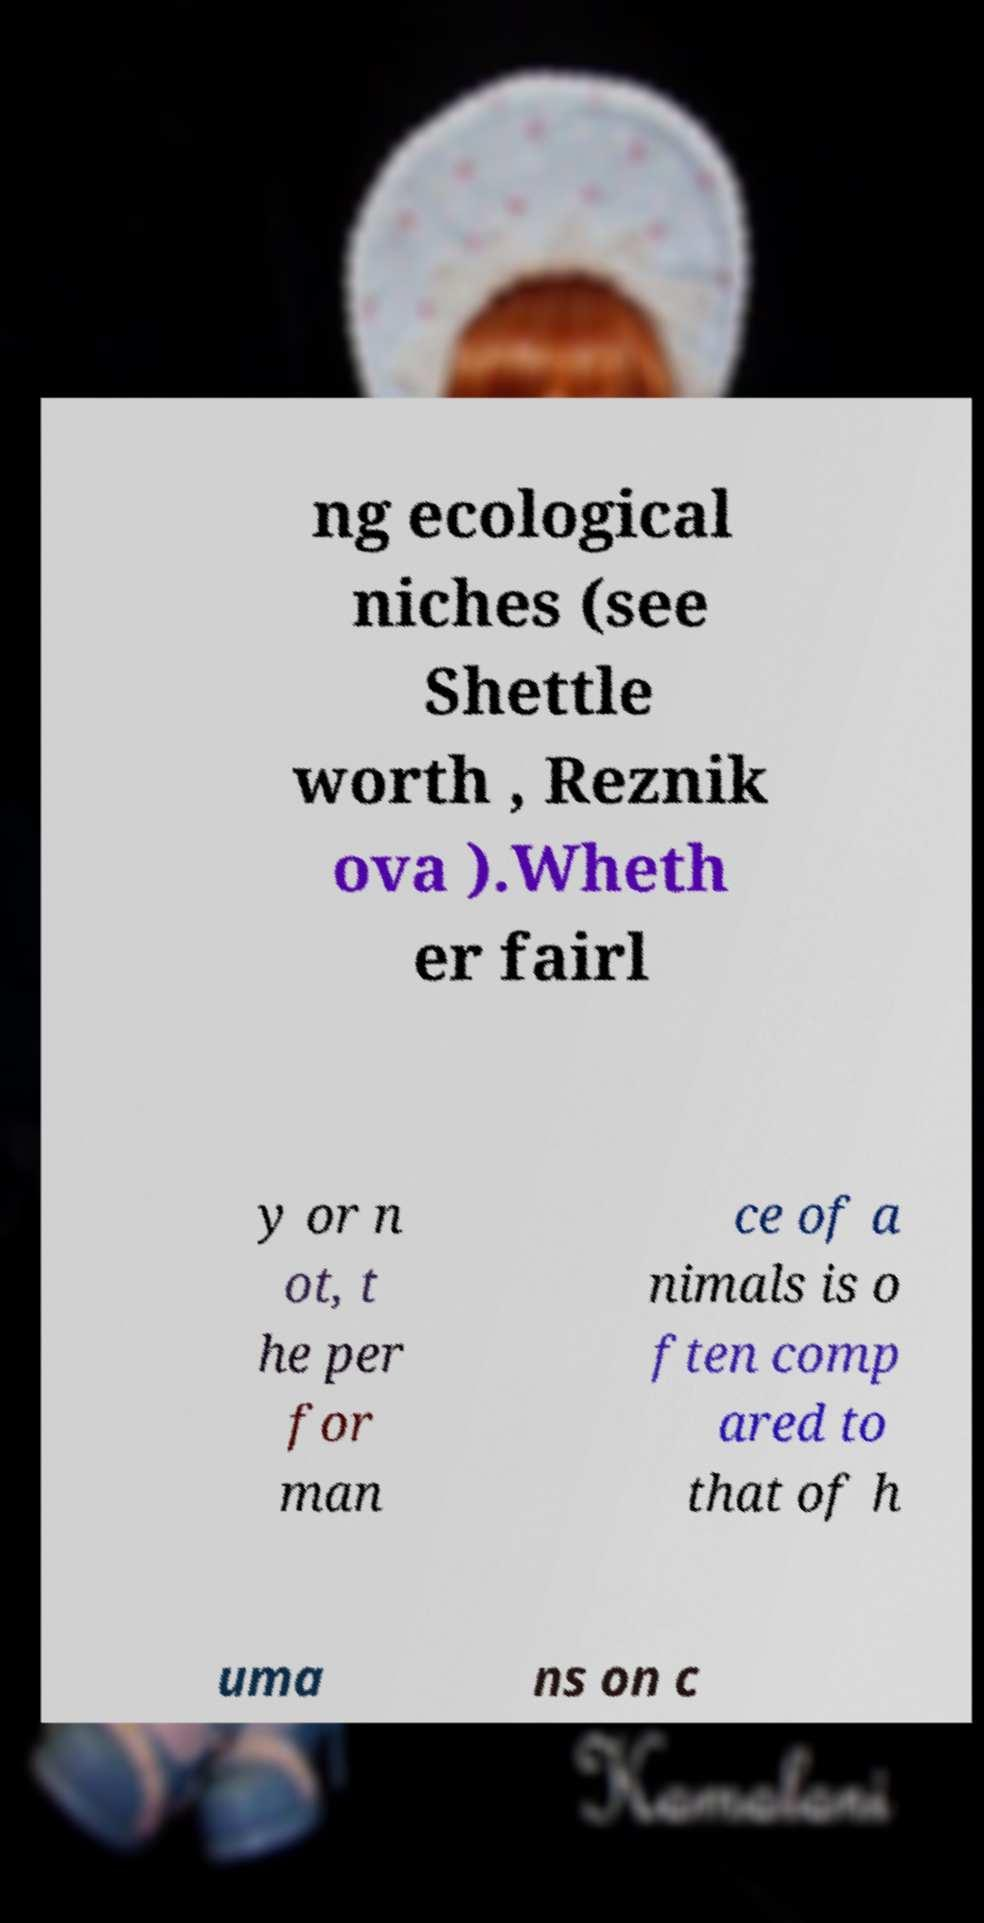For documentation purposes, I need the text within this image transcribed. Could you provide that? ng ecological niches (see Shettle worth , Reznik ova ).Wheth er fairl y or n ot, t he per for man ce of a nimals is o ften comp ared to that of h uma ns on c 